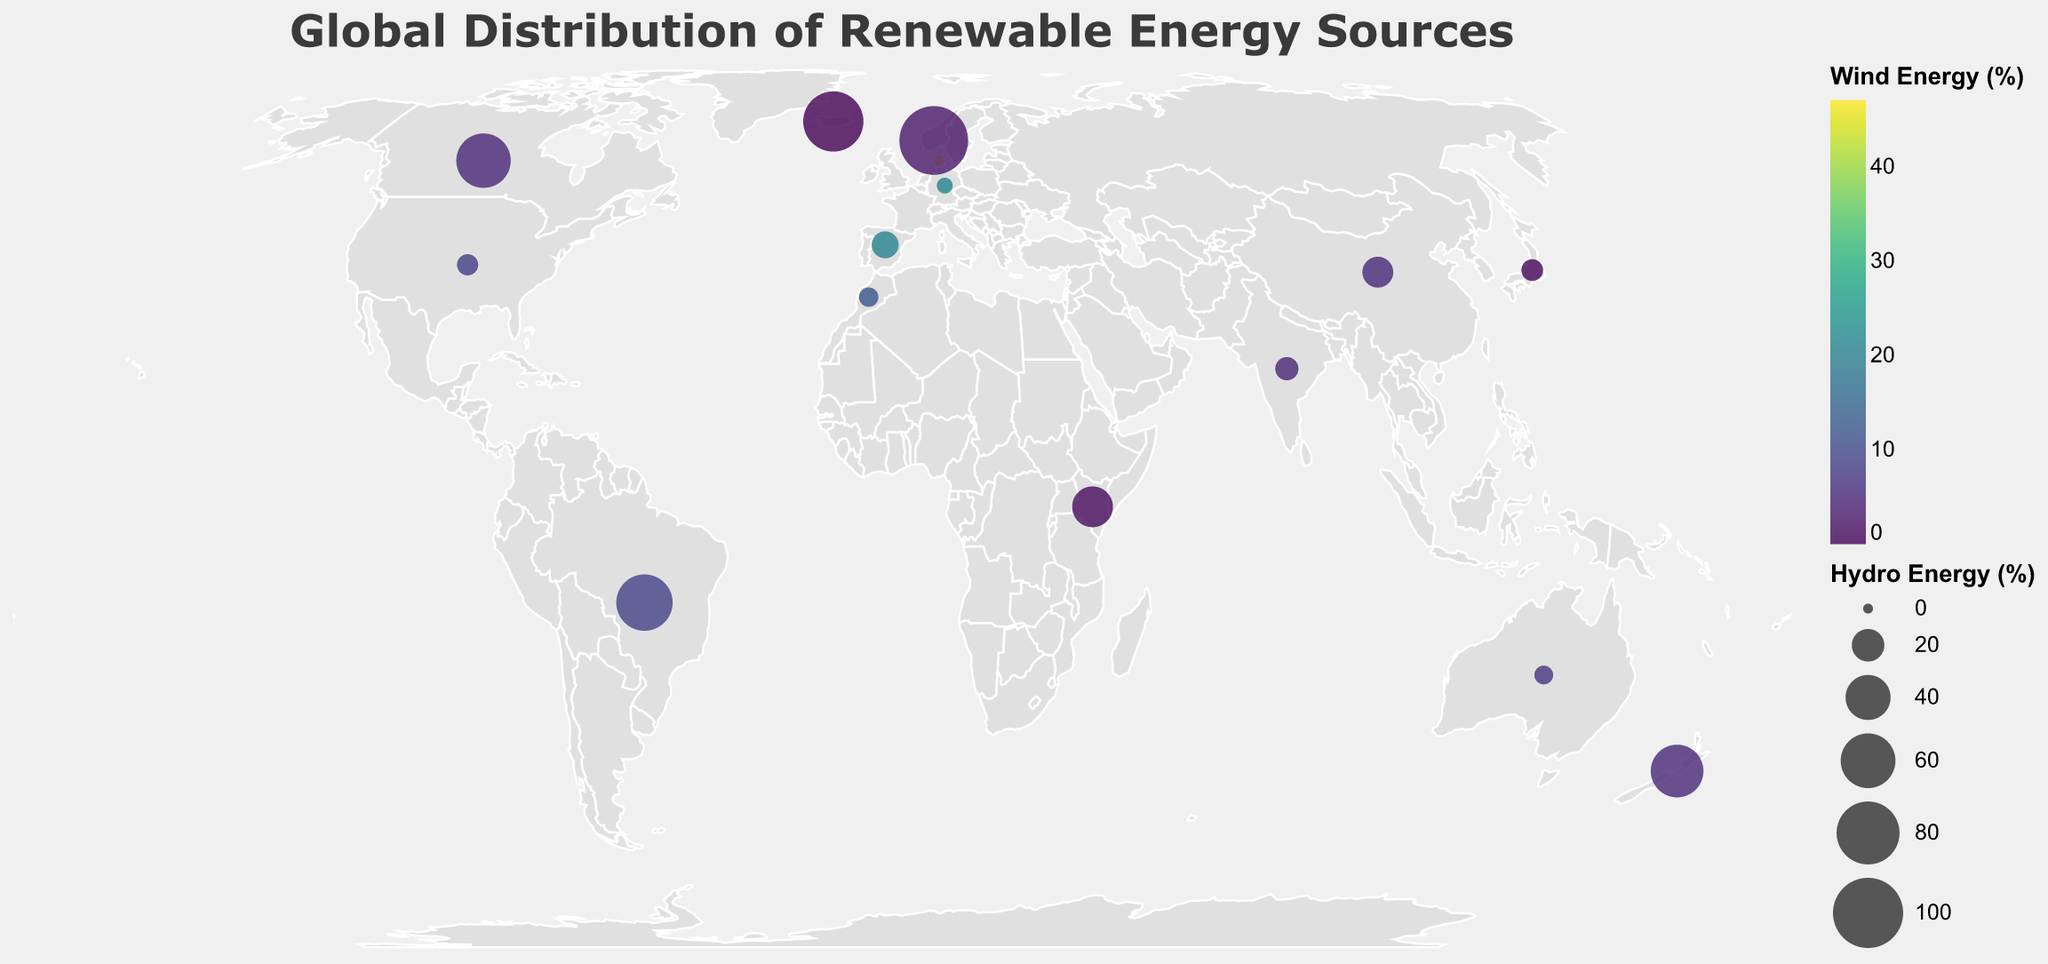What percentage of energy in Germany comes from solar sources? Look at the tooltip for Germany and observe the value corresponding to "Solar".
Answer: 8.2% Which country has the highest percentage of hydro energy? Examine the tooltip values under "Hydro" and identify the highest one.
Answer: Norway Among Japan and Spain, which country has a higher percentage of wind energy? Compare the "Wind" values in the tooltips for Japan and Spain.
Answer: Spain What's the title of the figure? Read the text at the top of the figure.
Answer: Global Distribution of Renewable Energy Sources Which country appears to rely most on geothermal energy? Identify the country with the highest percentage under "Geothermal" in the tooltips.
Answer: Kenya How does the hydro energy percentage in Brazil compare to that in Canada? Compare the "Hydro" values in the tooltips for Brazil and Canada.
Answer: Brazil has a higher hydro percentage than Canada What is the average percentage of solar energy for Germany, Australia, and Spain? Sum the values of "Solar" for Germany, Australia, and Spain, then divide by 3: (8.2 + 7.9 + 5.2) / 3.
Answer: 7.1% Which country has the smallest percentage of wind energy and what is that value? Locate the smallest "Wind" value in the tooltips and identify the country.
Answer: Japan, 0.7% Is there any country with 0% in more than two renewable energy sources? If yes, which country? Find a country in the tooltips with 0% in more than two sources.
Answer: Iceland Which continent appears to have a high reliance on hydro energy based on the plotted data? Observe the clustering and relative size of circles indicating hydro energy within each continent's regions.
Answer: South America 